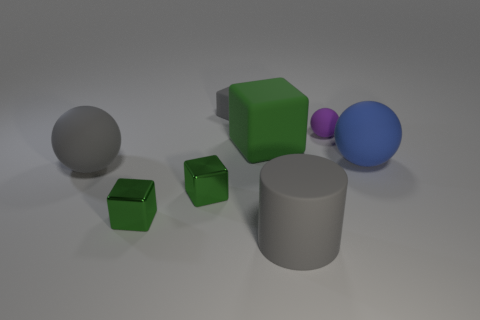There is a tiny object that is the same material as the tiny ball; what is its shape?
Make the answer very short. Cube. Are there any other things that are the same color as the matte cylinder?
Ensure brevity in your answer.  Yes. What number of purple metal balls are there?
Provide a succinct answer. 0. What shape is the gray matte thing that is in front of the gray cube and behind the rubber cylinder?
Your answer should be compact. Sphere. There is a big gray object that is in front of the large matte sphere left of the ball that is behind the large blue ball; what is its shape?
Offer a very short reply. Cylinder. What material is the object that is both in front of the gray rubber sphere and to the right of the gray rubber block?
Give a very brief answer. Rubber. How many gray things are the same size as the blue sphere?
Your answer should be compact. 2. What number of metallic objects are either small spheres or green cubes?
Provide a short and direct response. 2. What is the material of the big green thing?
Provide a short and direct response. Rubber. What number of big blue matte balls are to the left of the matte cylinder?
Ensure brevity in your answer.  0. 